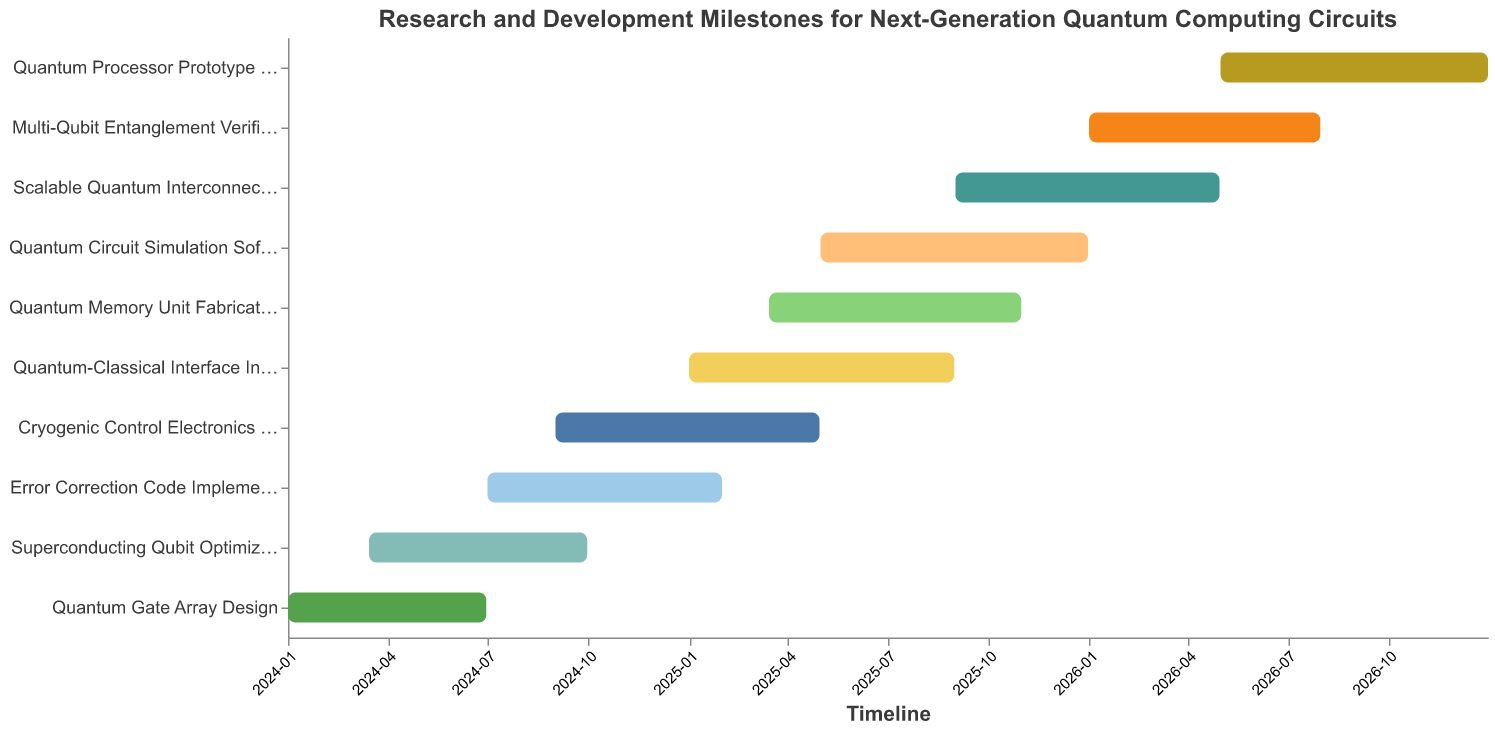How many tasks are displayed in the Gantt chart? To determine the number of tasks, count the unique task names listed on the y-axis in the Gantt chart. In this case, all task names are listed line by line.
Answer: 10 Which task has the longest duration and how long is it? To find the task with the longest duration, refer to the Duration field in the tooltip or data points and identify the maximum value. The task "Quantum Circuit Simulation Software" has the longest duration as its bar extends for the most days (245).
Answer: Quantum Circuit Simulation Software, 245 days When does the "Quantum Gate Array Design" task start and end? To identify the start and end dates for the specific task, find the bar associated with "Quantum Gate Array Design" on the y-axis and refer to the start and end points on the x-axis or check the tooltip. The bar starts at "2024-01-01" and ends at "2024-06-30".
Answer: 2024-01-01, 2024-06-30 What tasks are active during July 2024? Look for bars that overlap with the time period of July 2024 on the x-axis. Visual inspection shows "Quantum Gate Array Design", "Superconducting Qubit Optimization", and "Error Correction Code Implementation" are all active during that time period.
Answer: Quantum Gate Array Design, Superconducting Qubit Optimization, Error Correction Code Implementation Compare the duration of "Quantum-Classical Interface Integration" and "Quantum Memory Unit Fabrication" and state which one is longer. Refer to the Duration field or length of the bars for both tasks. "Quantum-Classical Interface Integration" has a duration of 243 days, and "Quantum Memory Unit Fabrication" has a duration of 231 days. The difference shows the former is longer.
Answer: Quantum-Classical Interface Integration Which tasks overlap with "Superconducting Qubit Optimization"? Identify the start and end dates of "Superconducting Qubit Optimization" (2024-03-15 to 2024-09-30). Then check which other tasks have bars overlapping within this date range: "Quantum Gate Array Design", "Error Correction Code Implementation", and "Cryogenic Control Electronics Development".
Answer: Quantum Gate Array Design, Error Correction Code Implementation, Cryogenic Control Electronics Development What is the gap (in days) between the end of "Quantum Gate Array Design" and the start of "Cryogenic Control Electronics Development"? Note the end date of "Quantum Gate Array Design" (2024-06-30) and the start date of "Cryogenic Control Electronics Development" (2024-09-01). Calculate the difference: from July 1 to September 1 is 62 days.
Answer: 62 days Which task that starts in 2025 has the shortest duration? Identify tasks that start in 2025 and compare their durations. "Quantum-Classical Interface Integration", "Quantum Memory Unit Fabrication", "Quantum Circuit Simulation Software", "Scalable Quantum Interconnect Design". The shortest duration is "Quantum Memory Unit Fabrication", 231 days.
Answer: Quantum Memory Unit Fabrication List the tasks that extend into 2026. Identify tasks with end dates in 2026. The tasks are "Scalable Quantum Interconnect Design", "Multi-Qubit Entanglement Verification", and "Quantum Processor Prototype Testing".
Answer: Scalable Quantum Interconnect Design, Multi-Qubit Entanglement Verification, Quantum Processor Prototype Testing 